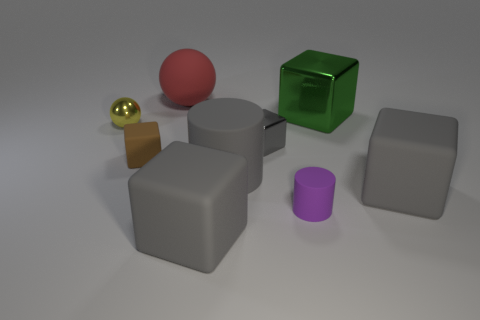How many gray cubes must be subtracted to get 1 gray cubes? 2 Subtract all yellow balls. How many gray blocks are left? 3 Subtract all green cubes. How many cubes are left? 4 Subtract all green shiny blocks. How many blocks are left? 4 Subtract all cyan blocks. Subtract all purple cylinders. How many blocks are left? 5 Add 1 big cyan rubber cubes. How many objects exist? 10 Subtract all cubes. How many objects are left? 4 Add 4 big cylinders. How many big cylinders are left? 5 Add 7 shiny cubes. How many shiny cubes exist? 9 Subtract 0 cyan spheres. How many objects are left? 9 